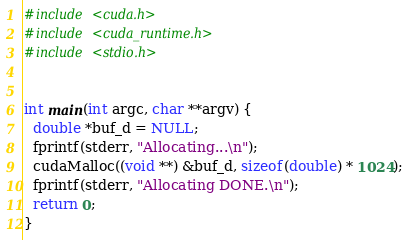<code> <loc_0><loc_0><loc_500><loc_500><_Cuda_>#include <cuda.h>
#include <cuda_runtime.h>
#include <stdio.h>


int main(int argc, char **argv) {
  double *buf_d = NULL;
  fprintf(stderr, "Allocating...\n");
  cudaMalloc((void **) &buf_d, sizeof(double) * 1024);
  fprintf(stderr, "Allocating DONE.\n");
  return 0;
}
</code> 